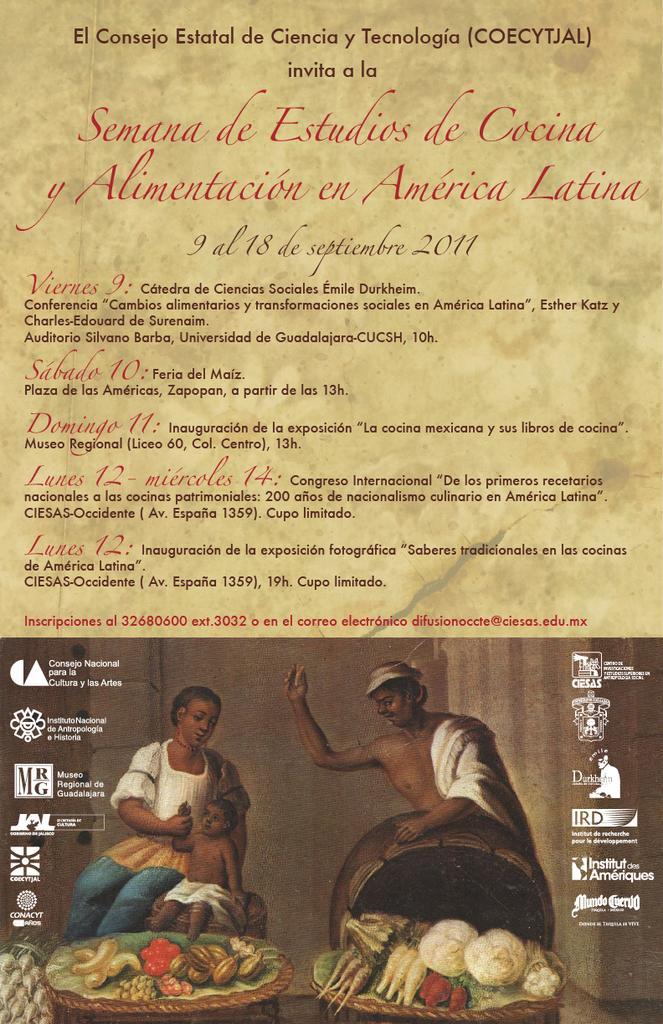In one or two sentences, can you explain what this image depicts? This is the image of the poster where there are painting of persons, few items on the table and some text in the poster. 